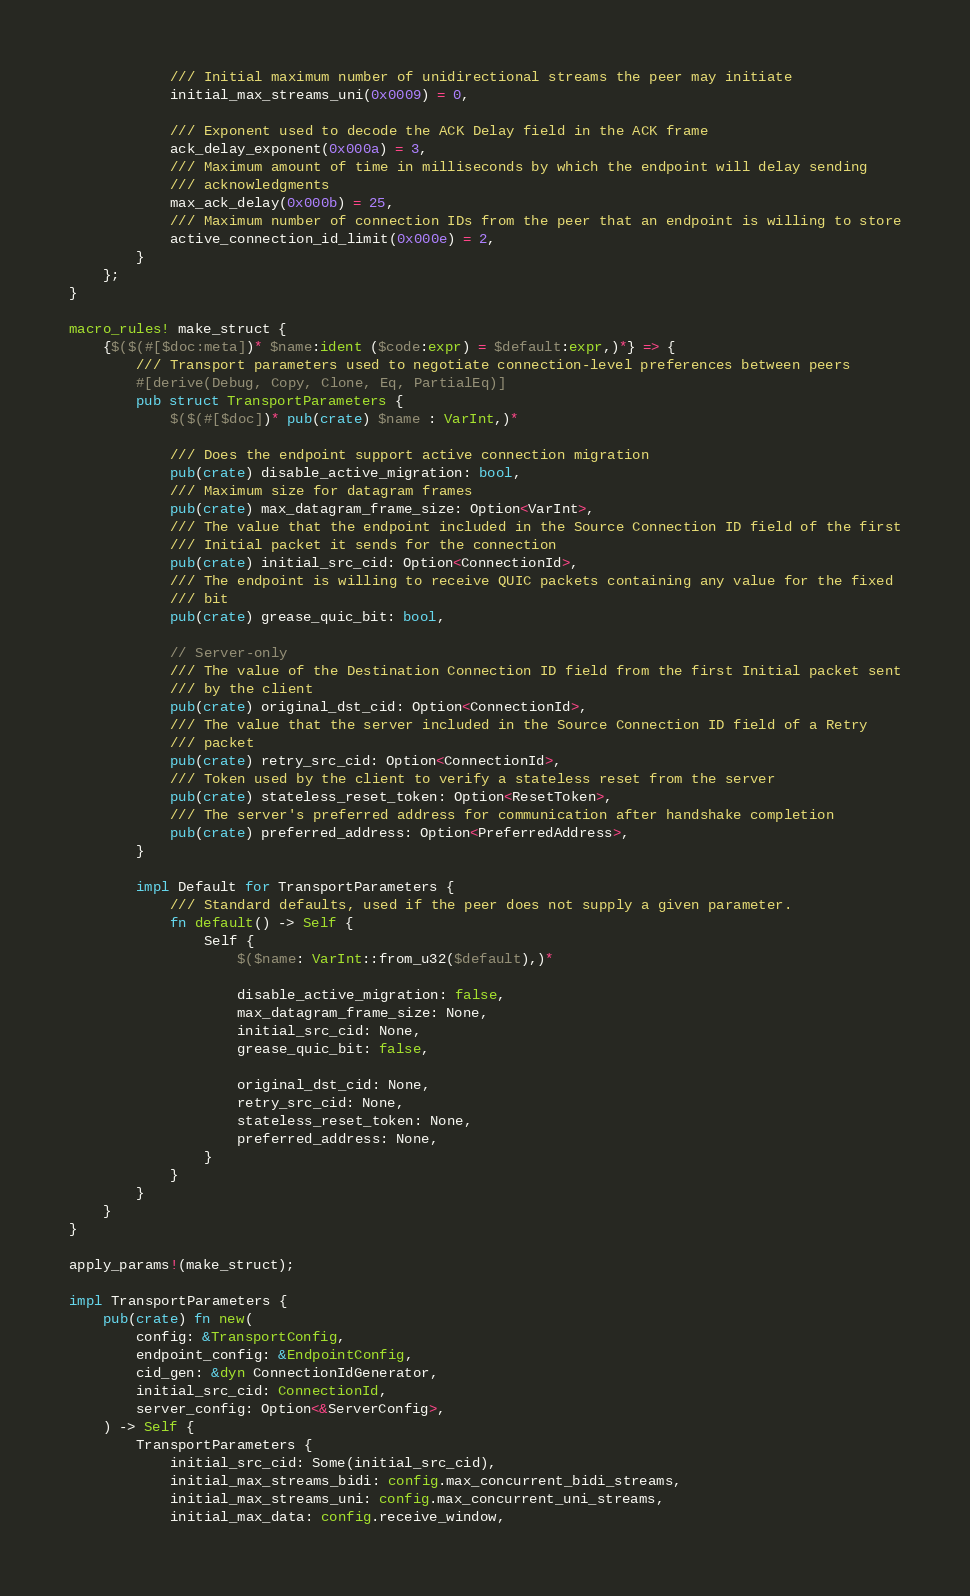<code> <loc_0><loc_0><loc_500><loc_500><_Rust_>            /// Initial maximum number of unidirectional streams the peer may initiate
            initial_max_streams_uni(0x0009) = 0,

            /// Exponent used to decode the ACK Delay field in the ACK frame
            ack_delay_exponent(0x000a) = 3,
            /// Maximum amount of time in milliseconds by which the endpoint will delay sending
            /// acknowledgments
            max_ack_delay(0x000b) = 25,
            /// Maximum number of connection IDs from the peer that an endpoint is willing to store
            active_connection_id_limit(0x000e) = 2,
        }
    };
}

macro_rules! make_struct {
    {$($(#[$doc:meta])* $name:ident ($code:expr) = $default:expr,)*} => {
        /// Transport parameters used to negotiate connection-level preferences between peers
        #[derive(Debug, Copy, Clone, Eq, PartialEq)]
        pub struct TransportParameters {
            $($(#[$doc])* pub(crate) $name : VarInt,)*

            /// Does the endpoint support active connection migration
            pub(crate) disable_active_migration: bool,
            /// Maximum size for datagram frames
            pub(crate) max_datagram_frame_size: Option<VarInt>,
            /// The value that the endpoint included in the Source Connection ID field of the first
            /// Initial packet it sends for the connection
            pub(crate) initial_src_cid: Option<ConnectionId>,
            /// The endpoint is willing to receive QUIC packets containing any value for the fixed
            /// bit
            pub(crate) grease_quic_bit: bool,

            // Server-only
            /// The value of the Destination Connection ID field from the first Initial packet sent
            /// by the client
            pub(crate) original_dst_cid: Option<ConnectionId>,
            /// The value that the server included in the Source Connection ID field of a Retry
            /// packet
            pub(crate) retry_src_cid: Option<ConnectionId>,
            /// Token used by the client to verify a stateless reset from the server
            pub(crate) stateless_reset_token: Option<ResetToken>,
            /// The server's preferred address for communication after handshake completion
            pub(crate) preferred_address: Option<PreferredAddress>,
        }

        impl Default for TransportParameters {
            /// Standard defaults, used if the peer does not supply a given parameter.
            fn default() -> Self {
                Self {
                    $($name: VarInt::from_u32($default),)*

                    disable_active_migration: false,
                    max_datagram_frame_size: None,
                    initial_src_cid: None,
                    grease_quic_bit: false,

                    original_dst_cid: None,
                    retry_src_cid: None,
                    stateless_reset_token: None,
                    preferred_address: None,
                }
            }
        }
    }
}

apply_params!(make_struct);

impl TransportParameters {
    pub(crate) fn new(
        config: &TransportConfig,
        endpoint_config: &EndpointConfig,
        cid_gen: &dyn ConnectionIdGenerator,
        initial_src_cid: ConnectionId,
        server_config: Option<&ServerConfig>,
    ) -> Self {
        TransportParameters {
            initial_src_cid: Some(initial_src_cid),
            initial_max_streams_bidi: config.max_concurrent_bidi_streams,
            initial_max_streams_uni: config.max_concurrent_uni_streams,
            initial_max_data: config.receive_window,</code> 